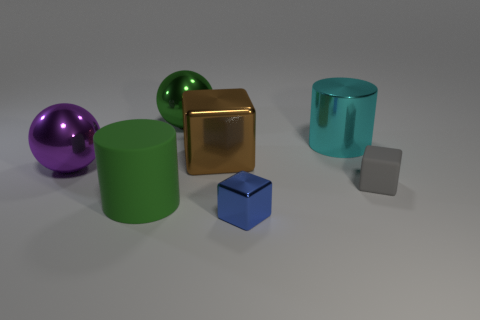How many things are either small blue rubber cylinders or cylinders?
Your answer should be very brief. 2. There is a rubber thing to the right of the brown shiny block; are there any small objects in front of it?
Your answer should be very brief. Yes. Is the number of gray things that are behind the small blue metal object greater than the number of small blocks on the left side of the big brown metallic block?
Give a very brief answer. Yes. How many matte cubes have the same color as the big matte object?
Ensure brevity in your answer.  0. Do the shiny sphere to the right of the large purple object and the big thing in front of the gray rubber block have the same color?
Keep it short and to the point. Yes. Are there any purple objects behind the large purple object?
Keep it short and to the point. No. What material is the gray block?
Provide a succinct answer. Rubber. What is the shape of the large green object that is behind the large purple ball?
Your answer should be compact. Sphere. What is the size of the sphere that is the same color as the large matte thing?
Provide a short and direct response. Large. Is there a brown block that has the same size as the green matte thing?
Offer a very short reply. Yes. 